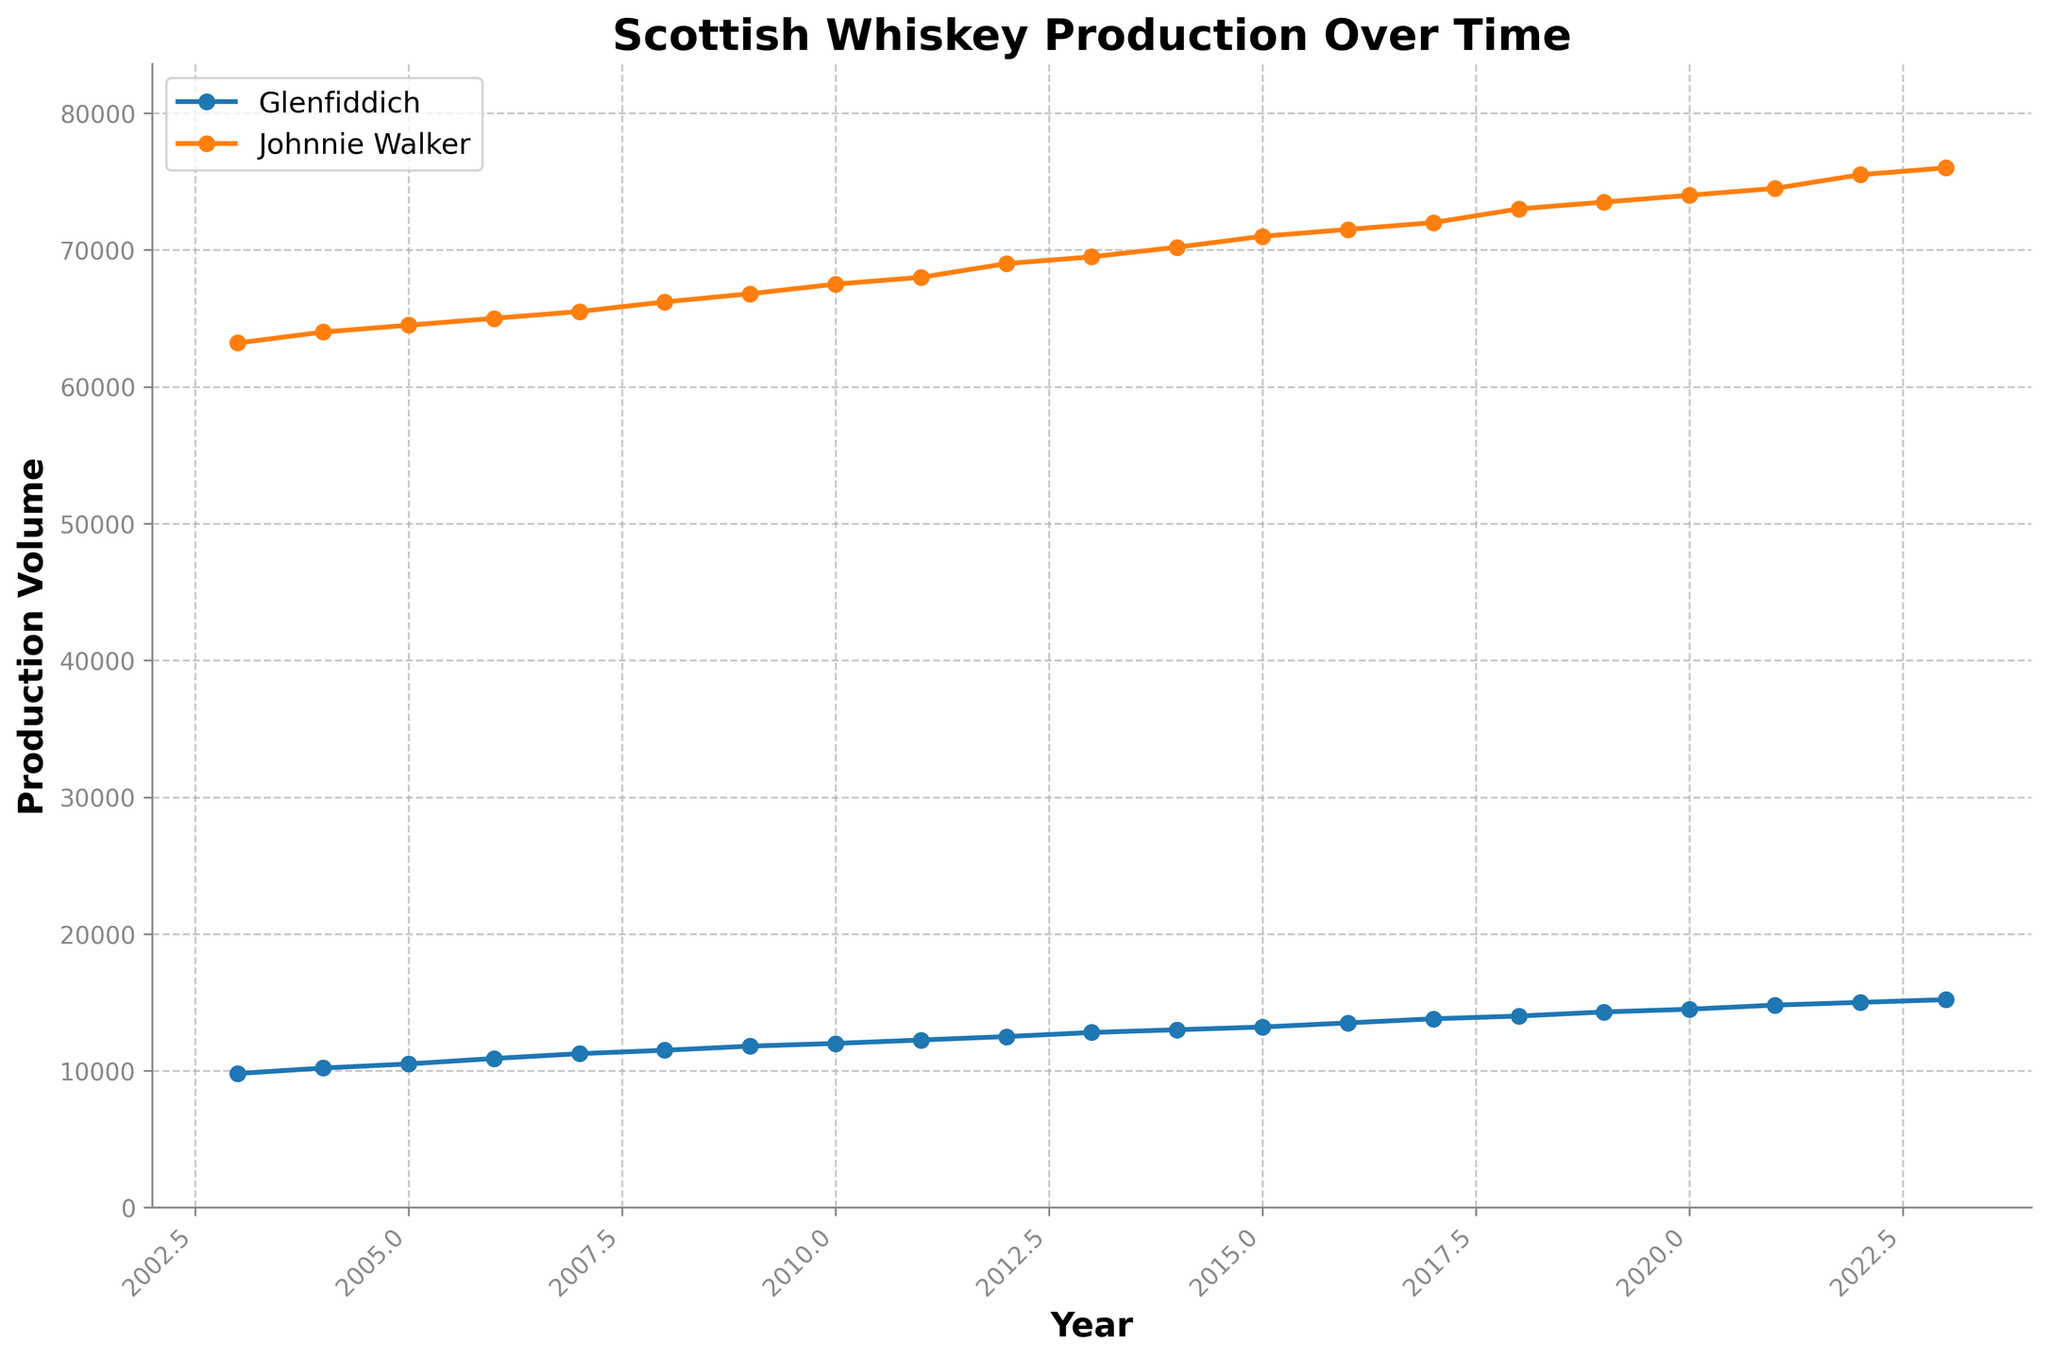What's the title of the figure? The title of the figure is displayed prominently at the top of the plot, making it easily identifiable without any need for interpretation.
Answer: Scottish Whiskey Production Over Time What is the production volume of Glenfiddich in 2023? Find the data point corresponding to Glenfiddich in the year 2023 on the plot and read off the volume directly.
Answer: 15,200 Which distillery had the higher production volume in 2010? Locate the 2010 data points for both Glenfiddich and Johnnie Walker and compare the production volumes indicated on the y-axis for that year.
Answer: Johnnie Walker In which year did Johnnie Walker’s production volume reach 70,000? Locate Johnnie Walker’s data line and find the year where the production volume intersects the 70,000 mark on the y-axis.
Answer: 2014 How many data points are plotted for Glenfiddich? Count the number of markers along the Glenfiddich line from 2003 to 2023. Each point represents one year's data.
Answer: 21 What is the difference in production volume between Glenfiddich and Johnnie Walker in 2022? Find the production volumes for both distilleries in 2022 and subtract Glenfiddich’s volume from Johnnie Walker’s volume.
Answer: 60,500 Which distillery shows a more consistent increase in production over the years? Look at the trend lines for both Glenfiddich and Johnnie Walker. Glenfiddich’s line shows a smoother, more consistent upward trajectory without large fluctuations compared to Johnnie Walker.
Answer: Glenfiddich By how much did Glenfiddich’s production volume increase from 2003 to 2023? Subtract the production volume of Glenfiddich in 2003 from the volume in 2023.
Answer: 5,400 From which year did Johnnie Walker’s production volume start surpassing 70,000 annually? Find the year where Johnnie Walker’s production volume consistently stays above 70,000 by checking each year sequentially on the plot.
Answer: 2015 